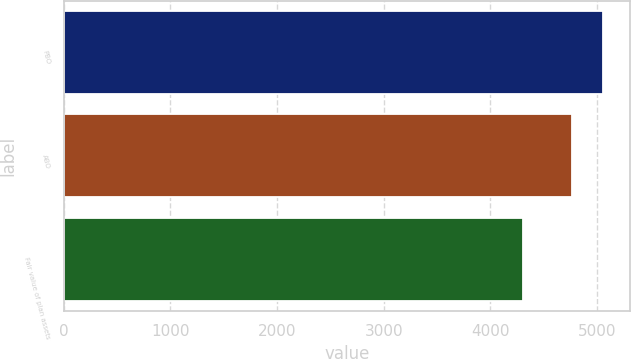Convert chart. <chart><loc_0><loc_0><loc_500><loc_500><bar_chart><fcel>PBO<fcel>ABO<fcel>Fair value of plan assets<nl><fcel>5055.2<fcel>4764.5<fcel>4303.8<nl></chart> 